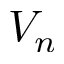<formula> <loc_0><loc_0><loc_500><loc_500>V _ { n }</formula> 